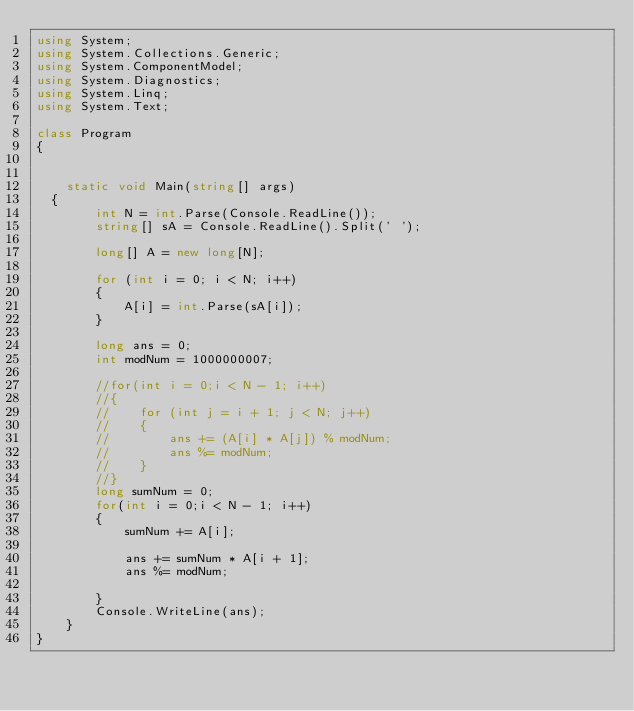Convert code to text. <code><loc_0><loc_0><loc_500><loc_500><_C#_>using System;
using System.Collections.Generic;
using System.ComponentModel;
using System.Diagnostics;
using System.Linq;
using System.Text;

class Program
{


    static void Main(string[] args)
	{
        int N = int.Parse(Console.ReadLine());
        string[] sA = Console.ReadLine().Split(' ');

        long[] A = new long[N];

        for (int i = 0; i < N; i++)
        {
            A[i] = int.Parse(sA[i]);
        }

        long ans = 0;
        int modNum = 1000000007;

        //for(int i = 0;i < N - 1; i++)
        //{
        //    for (int j = i + 1; j < N; j++)
        //    {
        //        ans += (A[i] * A[j]) % modNum;
        //        ans %= modNum;
        //    }
        //}
        long sumNum = 0;
        for(int i = 0;i < N - 1; i++)
        {
            sumNum += A[i];

            ans += sumNum * A[i + 1];
            ans %= modNum;

        }
        Console.WriteLine(ans);
    }
}</code> 